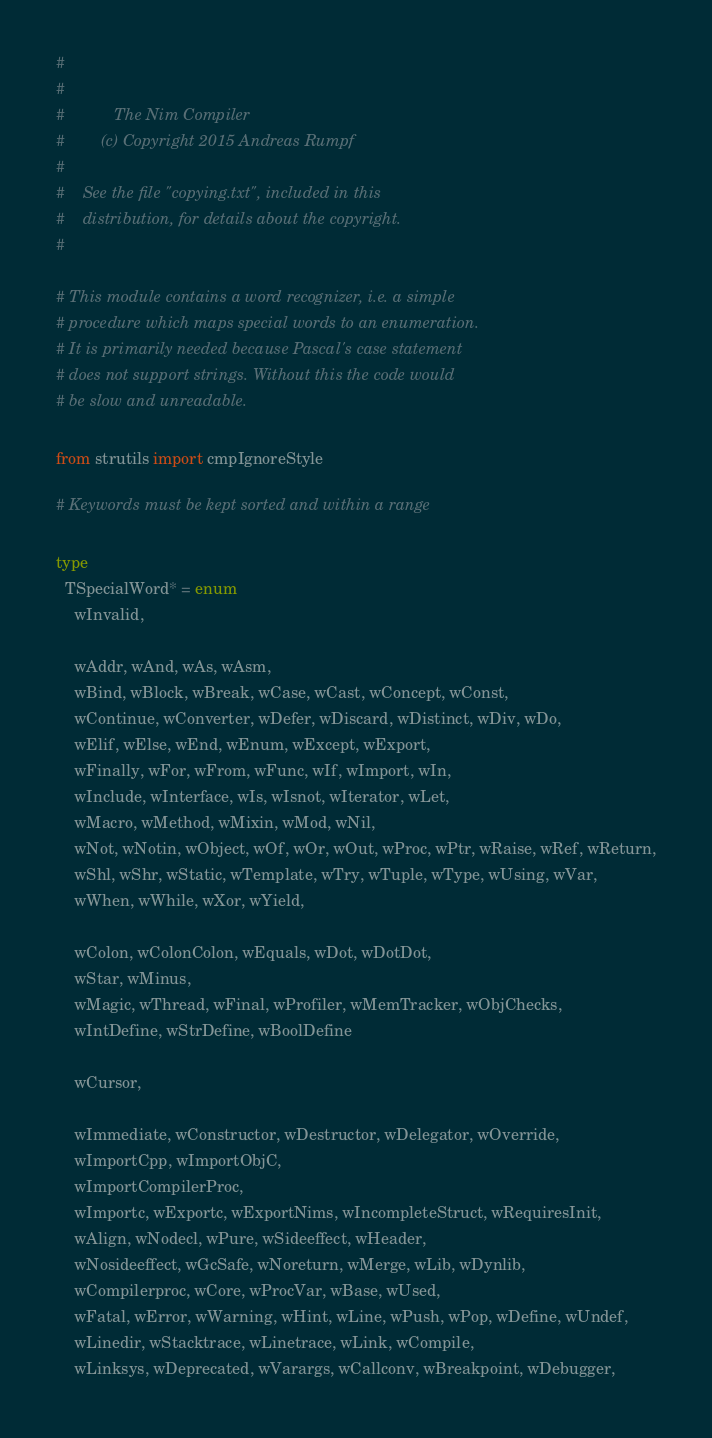<code> <loc_0><loc_0><loc_500><loc_500><_Nim_>#
#
#           The Nim Compiler
#        (c) Copyright 2015 Andreas Rumpf
#
#    See the file "copying.txt", included in this
#    distribution, for details about the copyright.
#

# This module contains a word recognizer, i.e. a simple
# procedure which maps special words to an enumeration.
# It is primarily needed because Pascal's case statement
# does not support strings. Without this the code would
# be slow and unreadable.

from strutils import cmpIgnoreStyle

# Keywords must be kept sorted and within a range

type
  TSpecialWord* = enum
    wInvalid,

    wAddr, wAnd, wAs, wAsm,
    wBind, wBlock, wBreak, wCase, wCast, wConcept, wConst,
    wContinue, wConverter, wDefer, wDiscard, wDistinct, wDiv, wDo,
    wElif, wElse, wEnd, wEnum, wExcept, wExport,
    wFinally, wFor, wFrom, wFunc, wIf, wImport, wIn,
    wInclude, wInterface, wIs, wIsnot, wIterator, wLet,
    wMacro, wMethod, wMixin, wMod, wNil,
    wNot, wNotin, wObject, wOf, wOr, wOut, wProc, wPtr, wRaise, wRef, wReturn,
    wShl, wShr, wStatic, wTemplate, wTry, wTuple, wType, wUsing, wVar,
    wWhen, wWhile, wXor, wYield,

    wColon, wColonColon, wEquals, wDot, wDotDot,
    wStar, wMinus,
    wMagic, wThread, wFinal, wProfiler, wMemTracker, wObjChecks,
    wIntDefine, wStrDefine, wBoolDefine

    wCursor,

    wImmediate, wConstructor, wDestructor, wDelegator, wOverride,
    wImportCpp, wImportObjC,
    wImportCompilerProc,
    wImportc, wExportc, wExportNims, wIncompleteStruct, wRequiresInit,
    wAlign, wNodecl, wPure, wSideeffect, wHeader,
    wNosideeffect, wGcSafe, wNoreturn, wMerge, wLib, wDynlib,
    wCompilerproc, wCore, wProcVar, wBase, wUsed,
    wFatal, wError, wWarning, wHint, wLine, wPush, wPop, wDefine, wUndef,
    wLinedir, wStacktrace, wLinetrace, wLink, wCompile,
    wLinksys, wDeprecated, wVarargs, wCallconv, wBreakpoint, wDebugger,</code> 